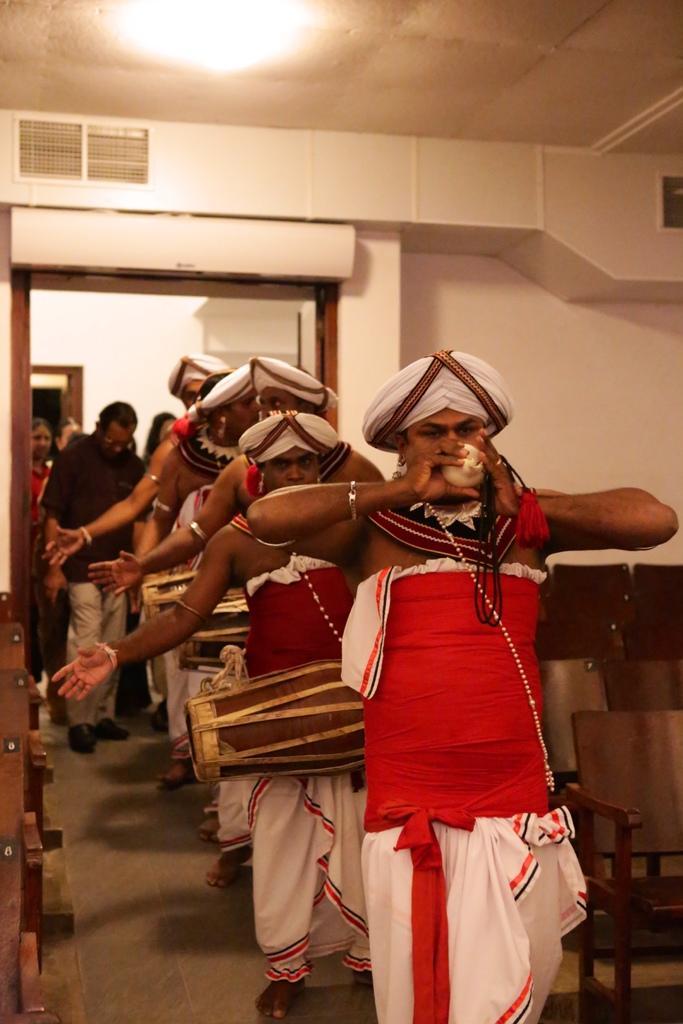Please provide a concise description of this image. In this image at the center there are few people playing the musical instruments. Behind them there are few other people. Beside them there are chairs. On the backside there is a wall. Beside the wall there is a door. On top of the roof there is a light. 